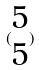Convert formula to latex. <formula><loc_0><loc_0><loc_500><loc_500>( \begin{matrix} 5 \\ 5 \end{matrix} )</formula> 